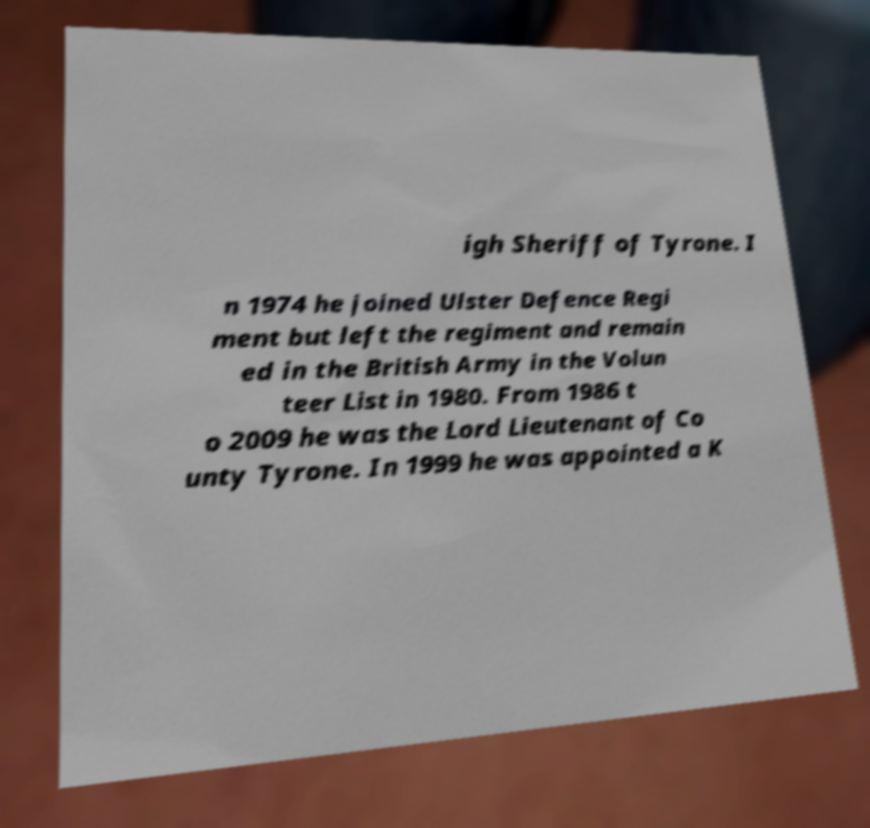Please identify and transcribe the text found in this image. igh Sheriff of Tyrone. I n 1974 he joined Ulster Defence Regi ment but left the regiment and remain ed in the British Army in the Volun teer List in 1980. From 1986 t o 2009 he was the Lord Lieutenant of Co unty Tyrone. In 1999 he was appointed a K 